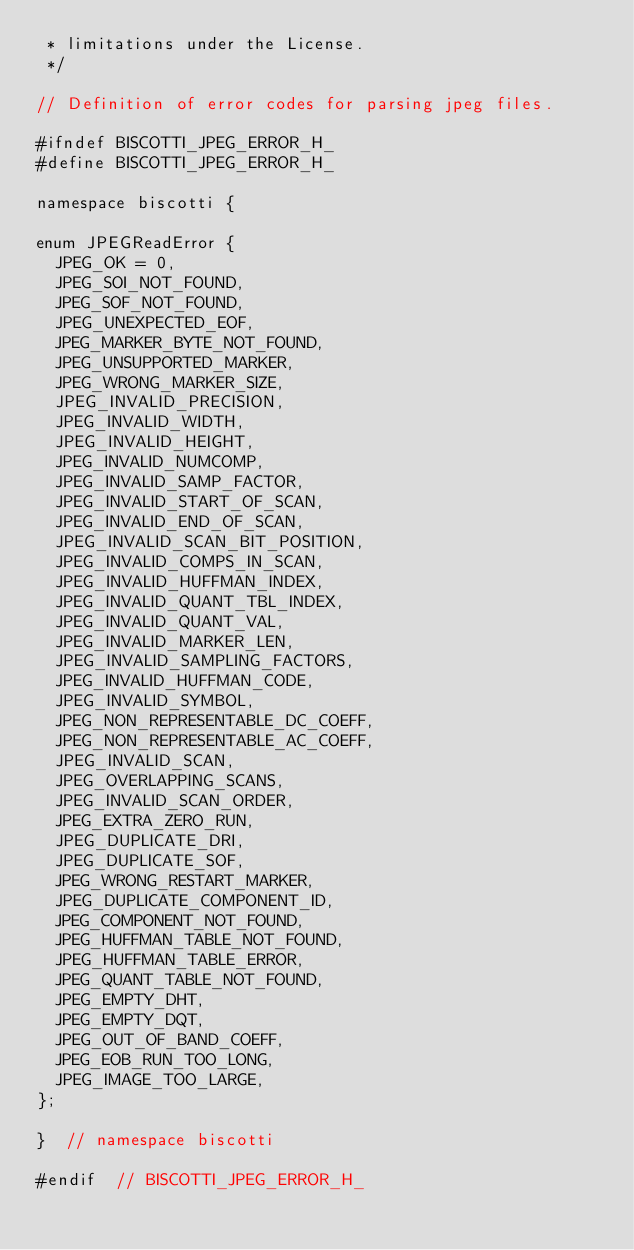Convert code to text. <code><loc_0><loc_0><loc_500><loc_500><_C_> * limitations under the License.
 */

// Definition of error codes for parsing jpeg files.

#ifndef BISCOTTI_JPEG_ERROR_H_
#define BISCOTTI_JPEG_ERROR_H_

namespace biscotti {

enum JPEGReadError {
  JPEG_OK = 0,
  JPEG_SOI_NOT_FOUND,
  JPEG_SOF_NOT_FOUND,
  JPEG_UNEXPECTED_EOF,
  JPEG_MARKER_BYTE_NOT_FOUND,
  JPEG_UNSUPPORTED_MARKER,
  JPEG_WRONG_MARKER_SIZE,
  JPEG_INVALID_PRECISION,
  JPEG_INVALID_WIDTH,
  JPEG_INVALID_HEIGHT,
  JPEG_INVALID_NUMCOMP,
  JPEG_INVALID_SAMP_FACTOR,
  JPEG_INVALID_START_OF_SCAN,
  JPEG_INVALID_END_OF_SCAN,
  JPEG_INVALID_SCAN_BIT_POSITION,
  JPEG_INVALID_COMPS_IN_SCAN,
  JPEG_INVALID_HUFFMAN_INDEX,
  JPEG_INVALID_QUANT_TBL_INDEX,
  JPEG_INVALID_QUANT_VAL,
  JPEG_INVALID_MARKER_LEN,
  JPEG_INVALID_SAMPLING_FACTORS,
  JPEG_INVALID_HUFFMAN_CODE,
  JPEG_INVALID_SYMBOL,
  JPEG_NON_REPRESENTABLE_DC_COEFF,
  JPEG_NON_REPRESENTABLE_AC_COEFF,
  JPEG_INVALID_SCAN,
  JPEG_OVERLAPPING_SCANS,
  JPEG_INVALID_SCAN_ORDER,
  JPEG_EXTRA_ZERO_RUN,
  JPEG_DUPLICATE_DRI,
  JPEG_DUPLICATE_SOF,
  JPEG_WRONG_RESTART_MARKER,
  JPEG_DUPLICATE_COMPONENT_ID,
  JPEG_COMPONENT_NOT_FOUND,
  JPEG_HUFFMAN_TABLE_NOT_FOUND,
  JPEG_HUFFMAN_TABLE_ERROR,
  JPEG_QUANT_TABLE_NOT_FOUND,
  JPEG_EMPTY_DHT,
  JPEG_EMPTY_DQT,
  JPEG_OUT_OF_BAND_COEFF,
  JPEG_EOB_RUN_TOO_LONG,
  JPEG_IMAGE_TOO_LARGE,
};

}  // namespace biscotti

#endif  // BISCOTTI_JPEG_ERROR_H_
</code> 